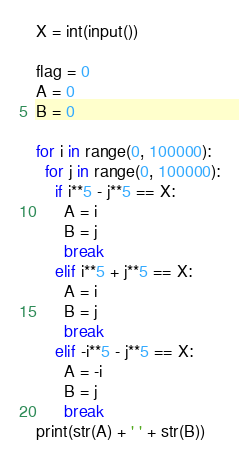Convert code to text. <code><loc_0><loc_0><loc_500><loc_500><_Python_>X = int(input())
 
flag = 0
A = 0
B = 0
 
for i in range(0, 100000):
  for j in range(0, 100000):
    if i**5 - j**5 == X:
      A = i
      B = j
      break
    elif i**5 + j**5 == X:
      A = i
      B = j
      break
    elif -i**5 - j**5 == X:
      A = -i
      B = j
      break
print(str(A) + ' ' + str(B))</code> 